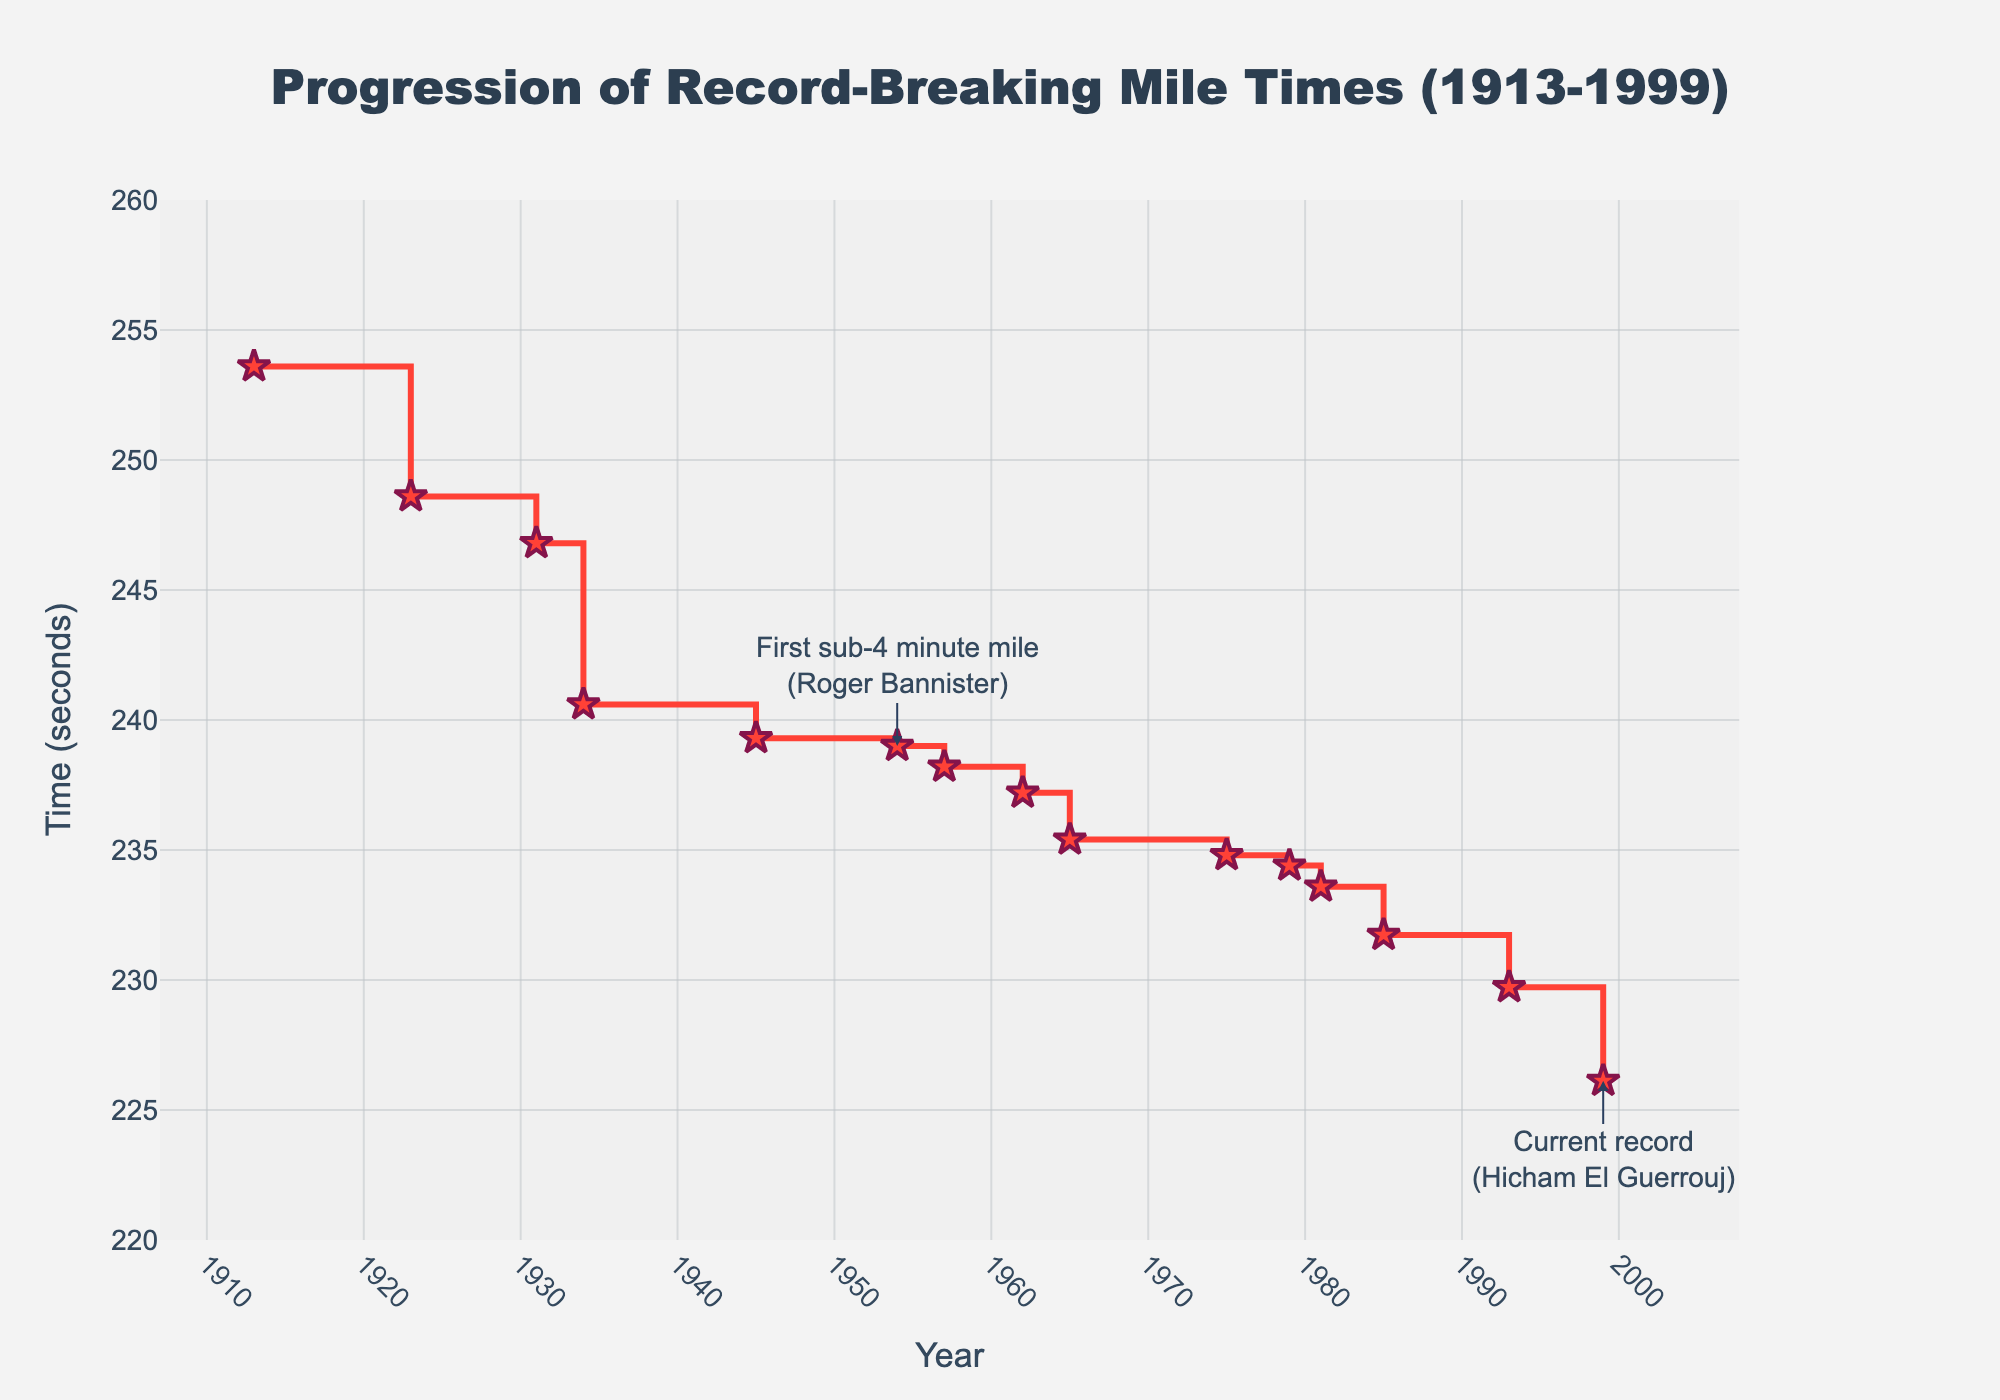what is the title of the plot? The title is usually located at the top center of the plot and provides an overview of what the plot represents.
Answer: Progression of Record-Breaking Mile Times (1913-1999) Who held the record in 1954 and what was the time? By looking at the x-axis for the year 1954 and checking the corresponding data point, we can see who held the record and the recorded time.
Answer: Roger Bannister, 239.0 seconds How many times was the record broken between 1913 and 1999? Count the number of data points or markers on the stair plot; each marker represents a new record being set.
Answer: 15 times What is the trend in mile times over the decades? Observe the overall direction of the stair plot line; if it generally moves downward, it indicates that the times are decreasing.
Answer: Decreasing trend In which year did the first sub-4-minute mile occur? Look for the annotation on the plot that signifies the first sub-4-minute mile.
Answer: 1954 Compare the mile time records between 1931 and 1993. Identify the mile times for the years 1931 (Jules Ladoumègue) and 1993 (Noureddine Morceli) and compare them.
Answer: 246.8 seconds in 1931 and 229.72 seconds in 1993 Which record had the smallest increment in mile time compared to the previous record, and by how much? Calculate the differences between consecutive records and identify the smallest one. The smallest increment can be observed visually or by calculation.
Answer: Roger Bannister's record in 1954, 0.3 seconds smaller than Gunder Hägg’s in 1945 What is the approximate average mile time record for the entire period? Sum all the mile times from each record and divide by the number of records. Sum = 253.6 + 248.6 + 246.8 + 240.6 + 239.3 + 239.0 + 238.2 + 237.2 + 235.4 + 234.8 + 234.4 + 233.59 + 231.73 + 229.72 + 226.12. Then divide by 15.
Answer: 238.47 seconds What is the largest single drop in mile time record and between which years did it occur? Identify the largest difference between two consecutive records by checking the y-values and noting the years between which this change occurred.
Answer: From 1931 to 1934, the time dropped by 6.2 seconds 